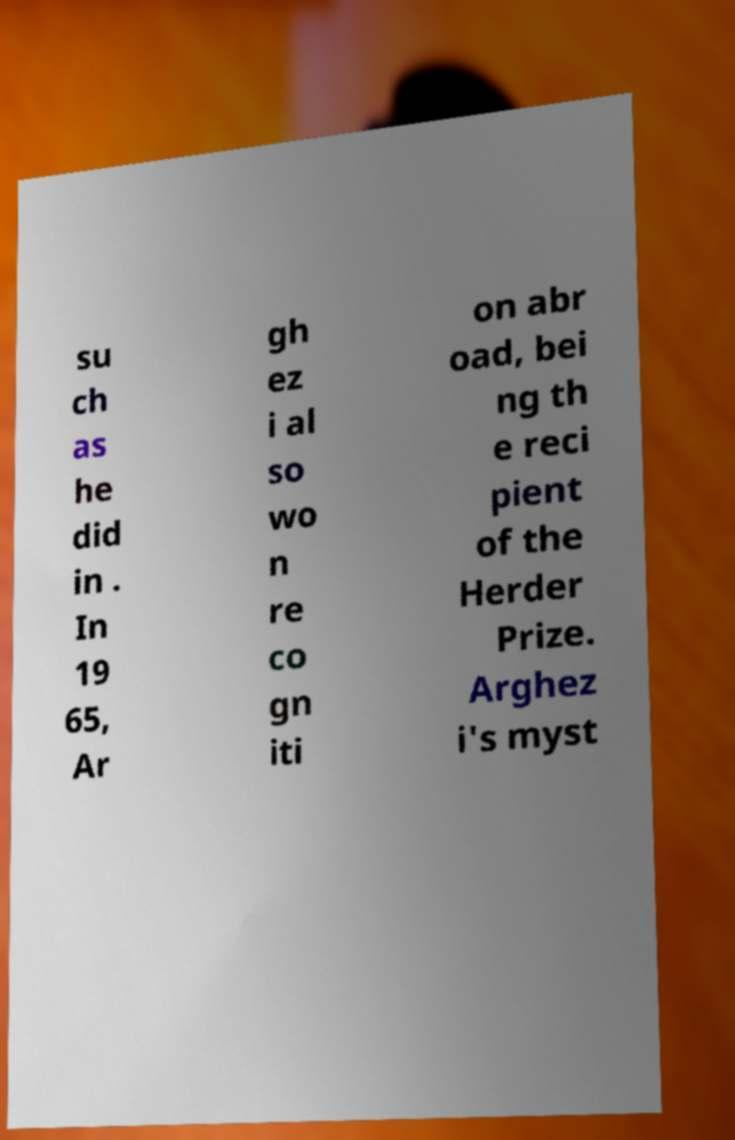Can you accurately transcribe the text from the provided image for me? su ch as he did in . In 19 65, Ar gh ez i al so wo n re co gn iti on abr oad, bei ng th e reci pient of the Herder Prize. Arghez i's myst 